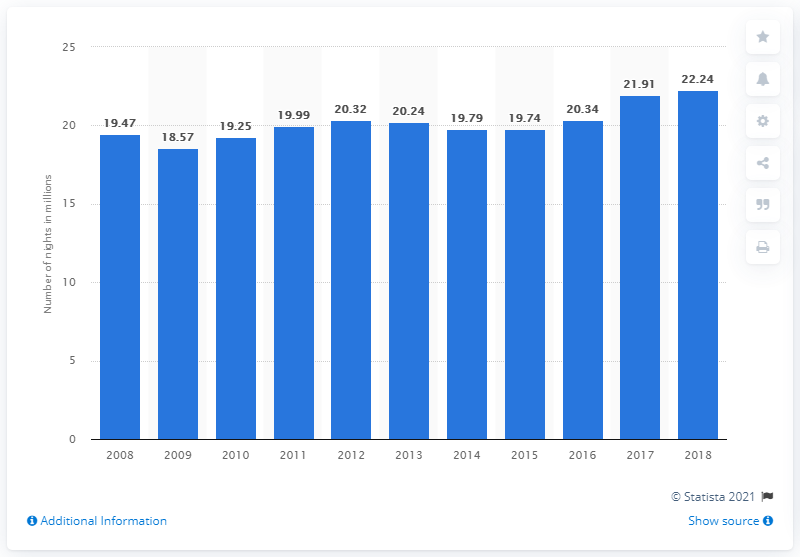Outline some significant characteristics in this image. During the period between 2008 and 2018, a total of 22.24 nights were spent at tourist accommodation establishments in Finland. 